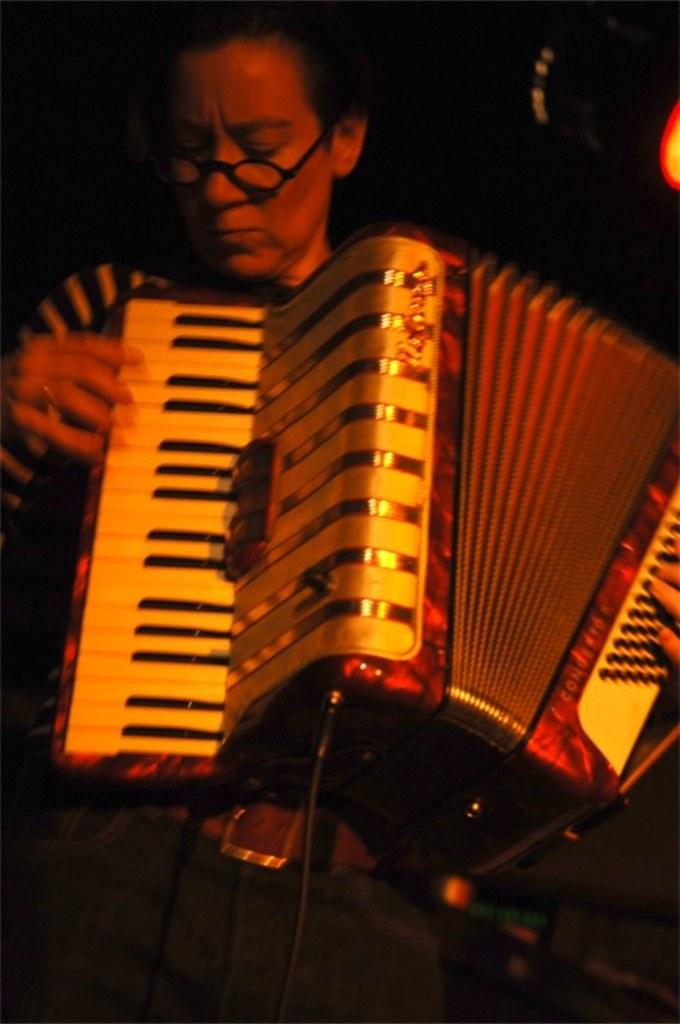What is the main subject of the image? The main subject of the image is a woman. What is the woman doing in the image? The woman is playing a music instrument in the image. Can you describe the lighting in the image? There is orange color light focusing on the woman in the image. What type of jam can be seen on the woman's instrument in the image? There is no jam present on the woman's instrument in the image. 